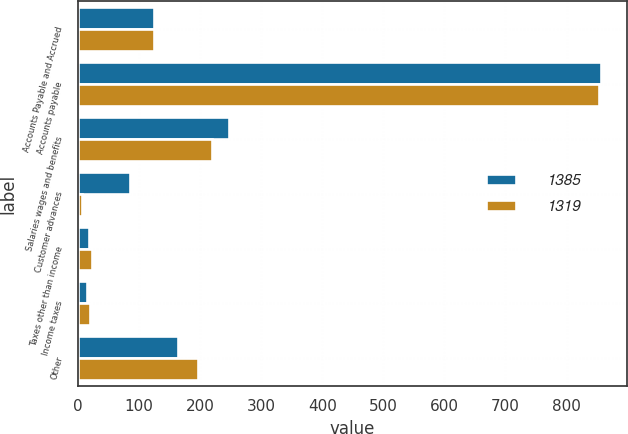Convert chart. <chart><loc_0><loc_0><loc_500><loc_500><stacked_bar_chart><ecel><fcel>Accounts Payable and Accrued<fcel>Accounts payable<fcel>Salaries wages and benefits<fcel>Customer advances<fcel>Taxes other than income<fcel>Income taxes<fcel>Other<nl><fcel>1385<fcel>124.5<fcel>856<fcel>247<fcel>85<fcel>18<fcel>15<fcel>164<nl><fcel>1319<fcel>124.5<fcel>854<fcel>220<fcel>6<fcel>23<fcel>20<fcel>196<nl></chart> 